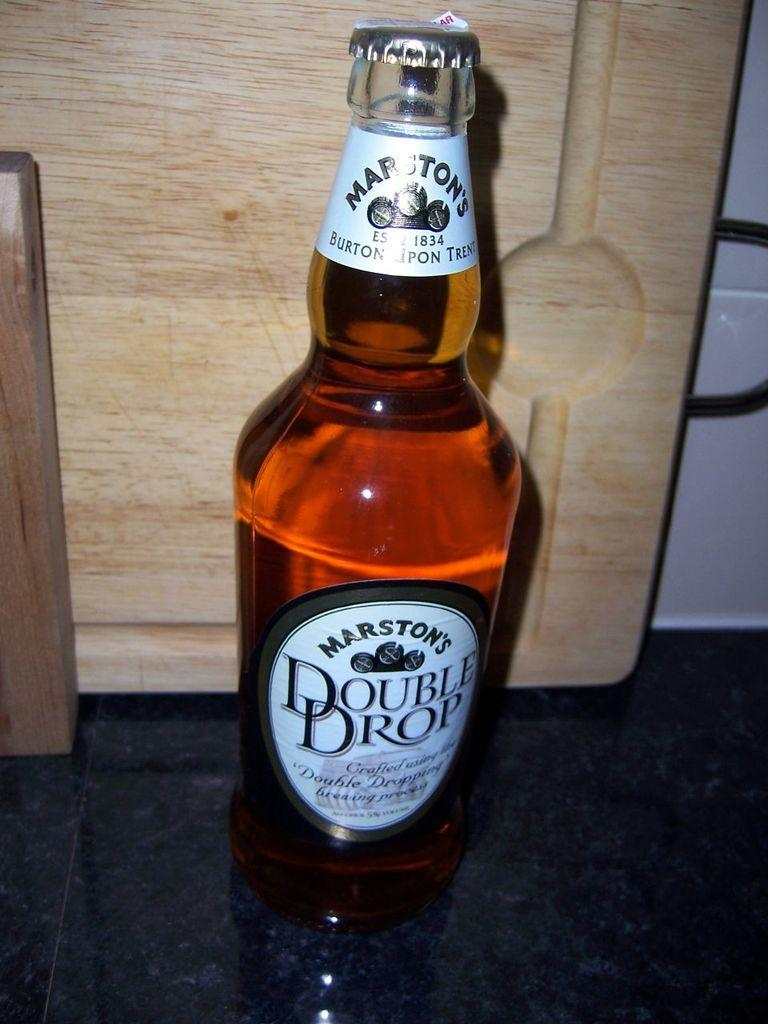<image>
Provide a brief description of the given image. Capped bottle o Marton's Double Drop on a counter 